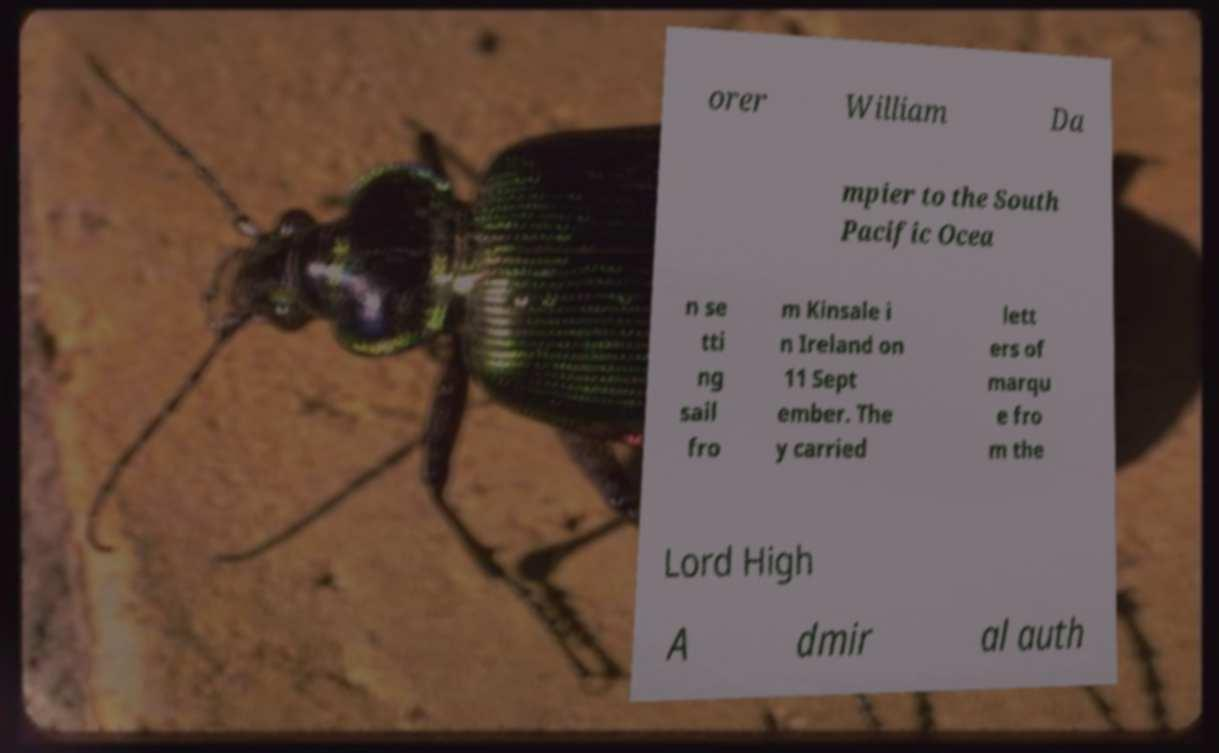Please identify and transcribe the text found in this image. orer William Da mpier to the South Pacific Ocea n se tti ng sail fro m Kinsale i n Ireland on 11 Sept ember. The y carried lett ers of marqu e fro m the Lord High A dmir al auth 